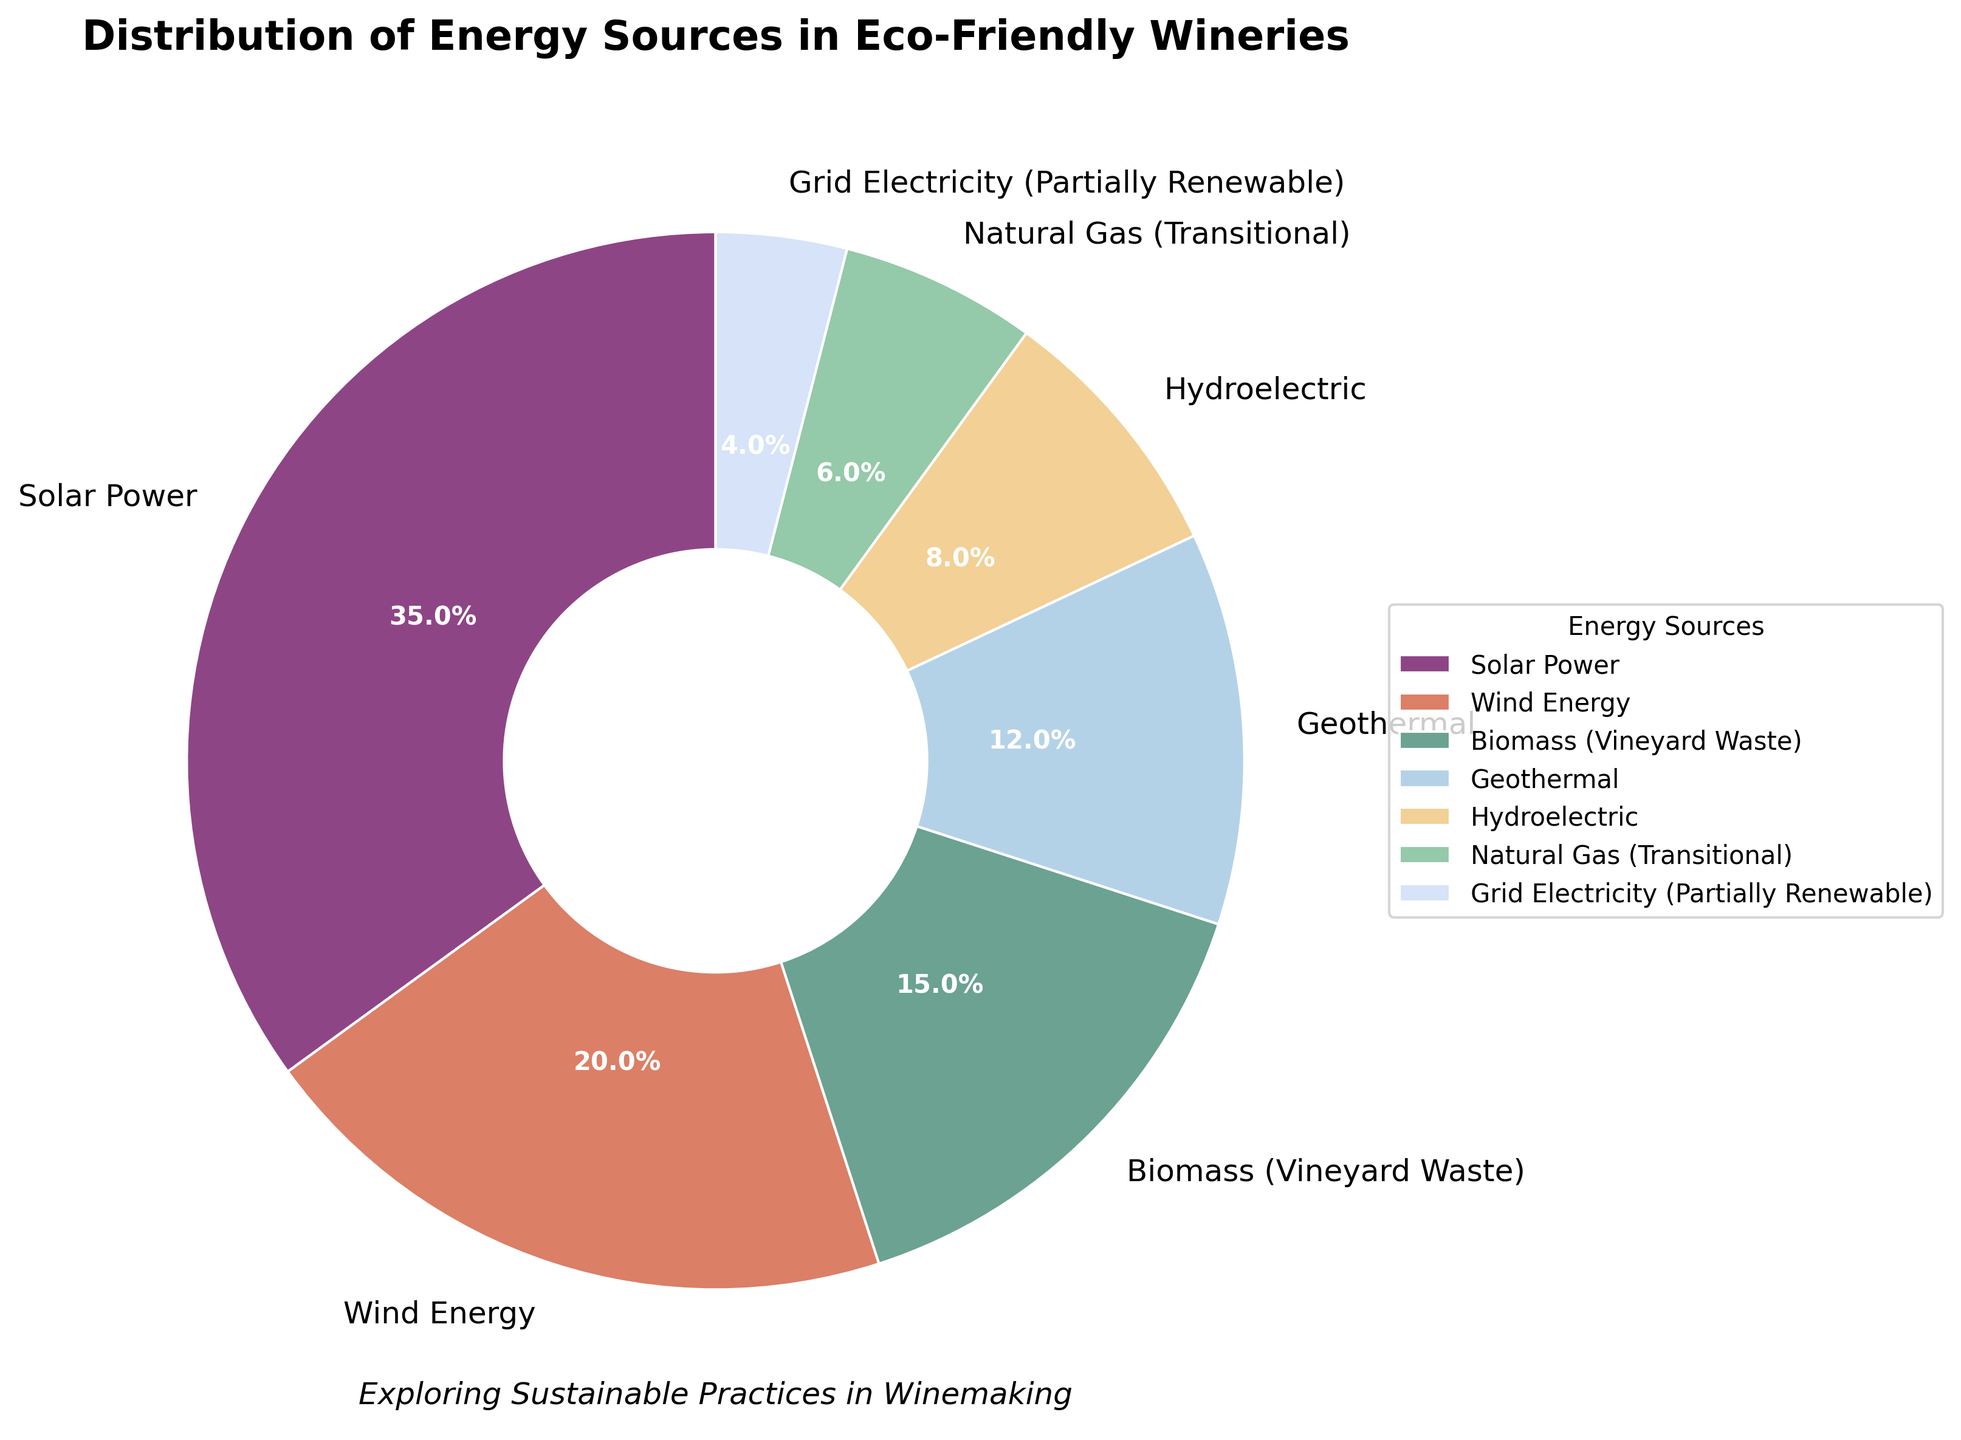What energy source has the largest share in eco-friendly wineries? The largest segment in the pie chart, which is indicated by both size and the percentage label, is "Solar Power" at 35%.
Answer: Solar Power Which energy source has the smallest share in the chart, and what is its percentage? The smallest segment in the pie chart, identified by the size and the percentage label, is "Grid Electricity (Partially Renewable)" at 4%.
Answer: Grid Electricity (Partially Renewable), 4% How much more percentage does Solar Power have compared to Wind Energy? Solar Power has a percentage of 35%. Wind Energy has a percentage of 20%. The difference is 35% - 20% = 15%.
Answer: 15% What is the combined percentage of energy sources that are not renewable (Natural Gas and Grid Electricity)? The percentages for Natural Gas (Transitional) and Grid Electricity (Partially Renewable) are 6% and 4%, respectively. The combined percentage is 6% + 4% = 10%.
Answer: 10% If we were to combine the percentages of Biomass and Geothermal energy sources, what would that sum be? The percentages for Biomass (Vineyard Waste) and Geothermal are 15% and 12%, respectively. The combined percentage is 15% + 12% = 27%.
Answer: 27% How does the share of biomass compare to the share of hydroelectric energy? The percentage for Biomass (Vineyard Waste) is 15%, and for Hydroelectric, it is 8%. Biomass has a larger share by 15% - 8% = 7%.
Answer: Biomass has 7% more than Hydroelectric Arrange the renewable energy sources from highest to lowest percentage. The renewable energy sources in descending order of their percentages are: Solar Power (35%), Wind Energy (20%), Biomass (15%), Geothermal (12%), and Hydroelectric (8%).
Answer: Solar Power, Wind Energy, Biomass, Geothermal, Hydroelectric 